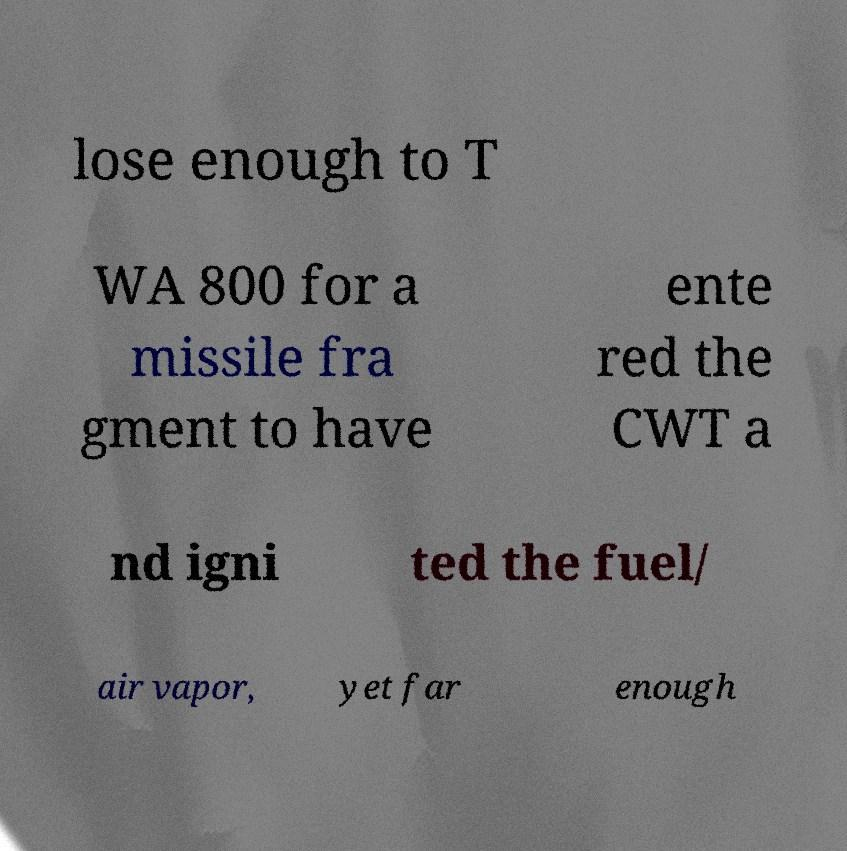Can you read and provide the text displayed in the image?This photo seems to have some interesting text. Can you extract and type it out for me? lose enough to T WA 800 for a missile fra gment to have ente red the CWT a nd igni ted the fuel/ air vapor, yet far enough 